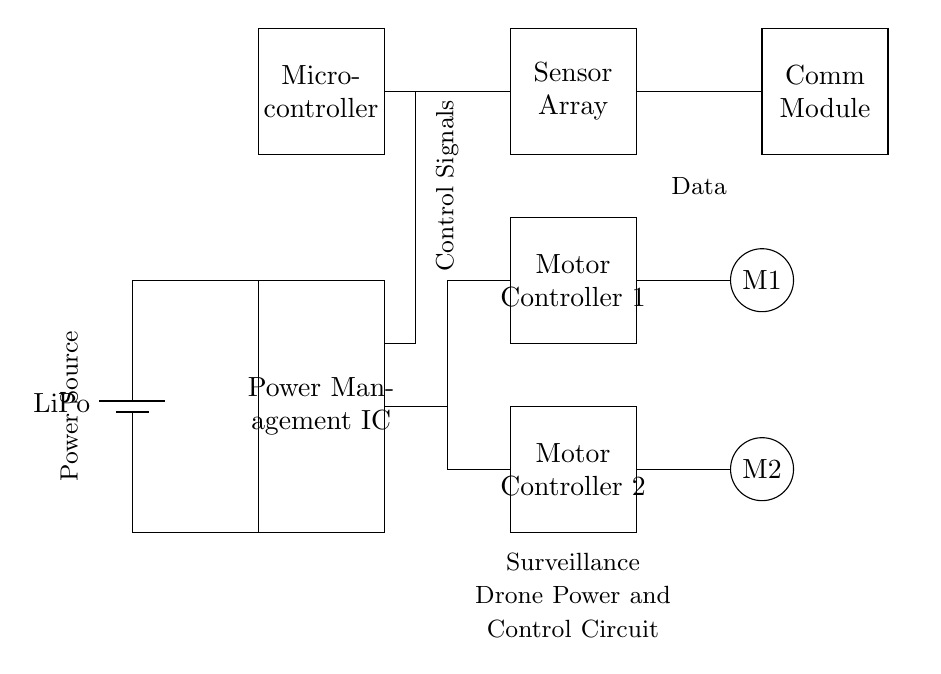What type of battery is used in this circuit? The circuit diagram shows a battery component labeled "LiPo," which indicates that the circuit uses a lithium polymer battery.
Answer: LiPo What does the Power Management IC do? The Power Management IC is responsible for regulating and distributing power to the other components in the circuit, ensuring stable operation and efficiency.
Answer: Regulates power Which component connects sensors and the microcontroller? The connections from the microcontroller to the sensor array indicate that these components are connected for data exchange and control signals.
Answer: Microcontroller How many motor controllers are present in the circuit? The diagram displays two rectangles labeled "Motor Controller 1" and "Motor Controller 2," representing two motor controllers in the circuit.
Answer: Two What is the role of the communication module? The communication module facilitates data transmission and reception, allowing the drone to communicate with external devices or systems.
Answer: Data communication Which components are directly powered by the battery? The battery is connected directly to the Power Management IC and subsequently to various components, implying that the Power Management IC distributes power to the motor controllers and the microcontroller.
Answer: Power Management IC and others How do the motor controllers connect to the motors? The motor controllers output signals to the motors, illustrated by lines connecting the motor controllers to the respective motor symbols, indicating controlled power delivery for motor operation.
Answer: Direct connections 